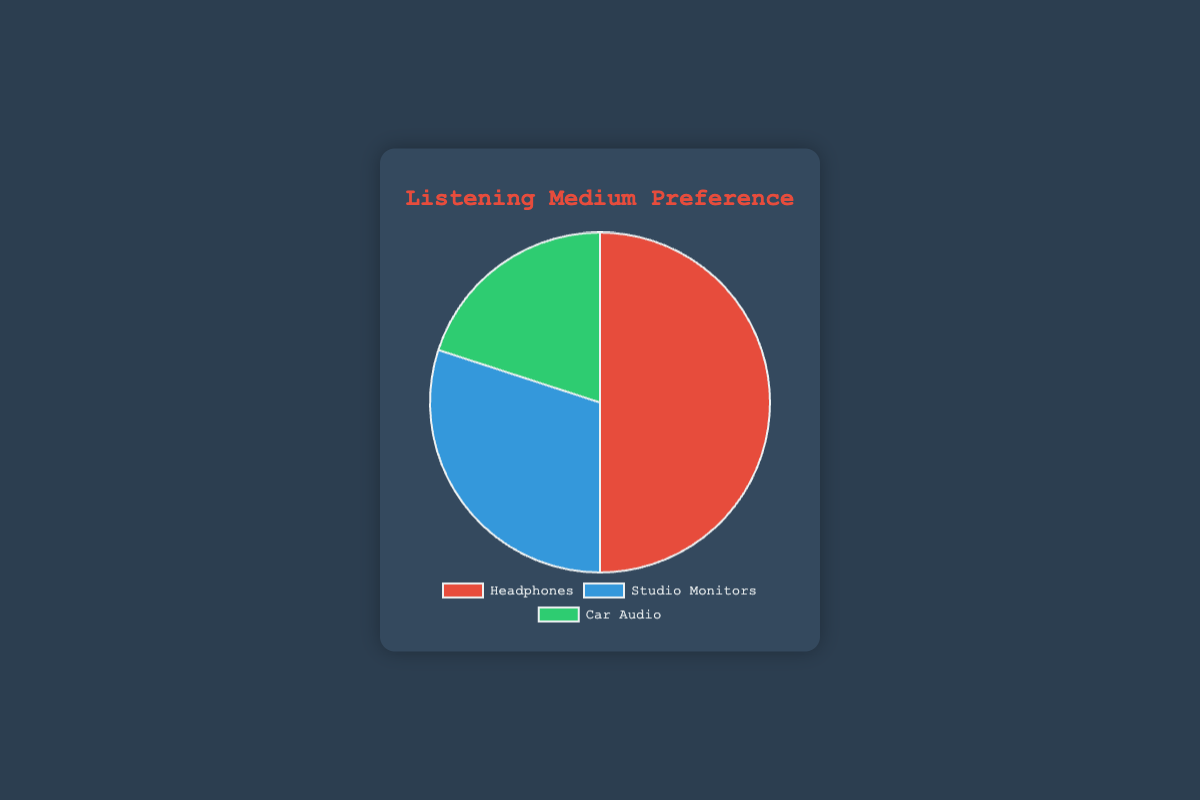What's the most preferred listening medium? Looking at the pie chart, the segment with the highest percentage is the one for headphones, which has 50%.
Answer: Headphones What is the combined percentage of people who prefer studio monitors and car audio? Adding the percentages for studio monitors (30%) and car audio (20%) gives 30% + 20% = 50%.
Answer: 50% Which listening medium is the least preferred? The smallest segment in the pie chart represents car audio, which has a percentage of 20%.
Answer: Car Audio How much more preferred are headphones compared to car audio? The percentage for headphones is 50% and for car audio is 20%. The difference is 50% - 20% = 30%.
Answer: 30% By what percentage do headphones lead over studio monitors? The percentage for headphones is 50% and for studio monitors is 30%. The difference is 50% - 30% = 20%.
Answer: 20% What color represents studio monitors in the pie chart? The pie chart uses three colors: red, blue, and green. Studio monitors are represented by the blue segment.
Answer: Blue Which two listening mediums combined make up a majority (over 50%) of the preferences? Combining headphones (50%) and any other segment would exceed 50%. So, headphones and any one of studio monitors (30%) or car audio (20%) would work.
Answer: Headphones and Studio Monitors What is the ratio of the preference for headphones to studio monitors? The percentage for headphones is 50% and for studio monitors is 30%. The ratio is 50:30, which simplifies to 5:3.
Answer: 5:3 If 100 clients were surveyed, how many prefer car audio? The percentage for car audio is 20%. So, 20% of 100 is 20 clients.
Answer: 20 clients 